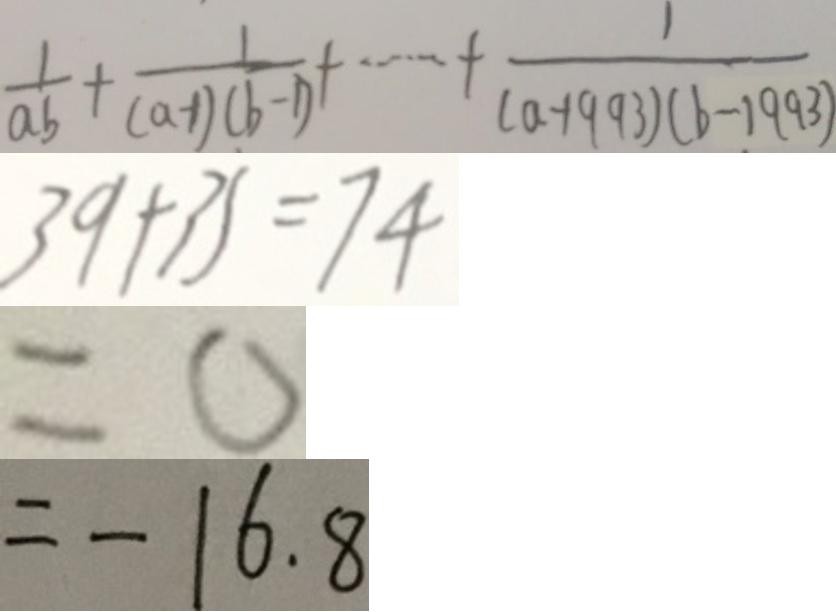Convert formula to latex. <formula><loc_0><loc_0><loc_500><loc_500>\frac { 1 } { a b } + \frac { 1 } { ( a - 1 ) ( b - 1 ) } + \cdots + \frac { 1 } { ( a - 1 9 9 3 ) ( b - 1 9 9 3 ) } 
 3 9 + 3 5 = 7 4 
 = 0 
 = - 1 6 . 8</formula> 